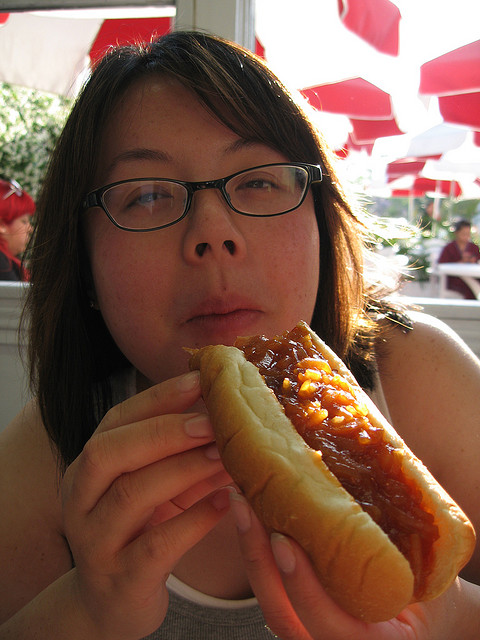How many people are visible? 2 